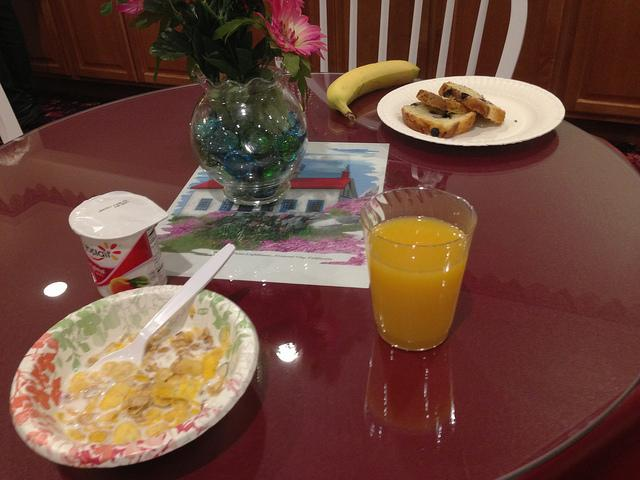What fruit used to prepare items here is darkest? orange 